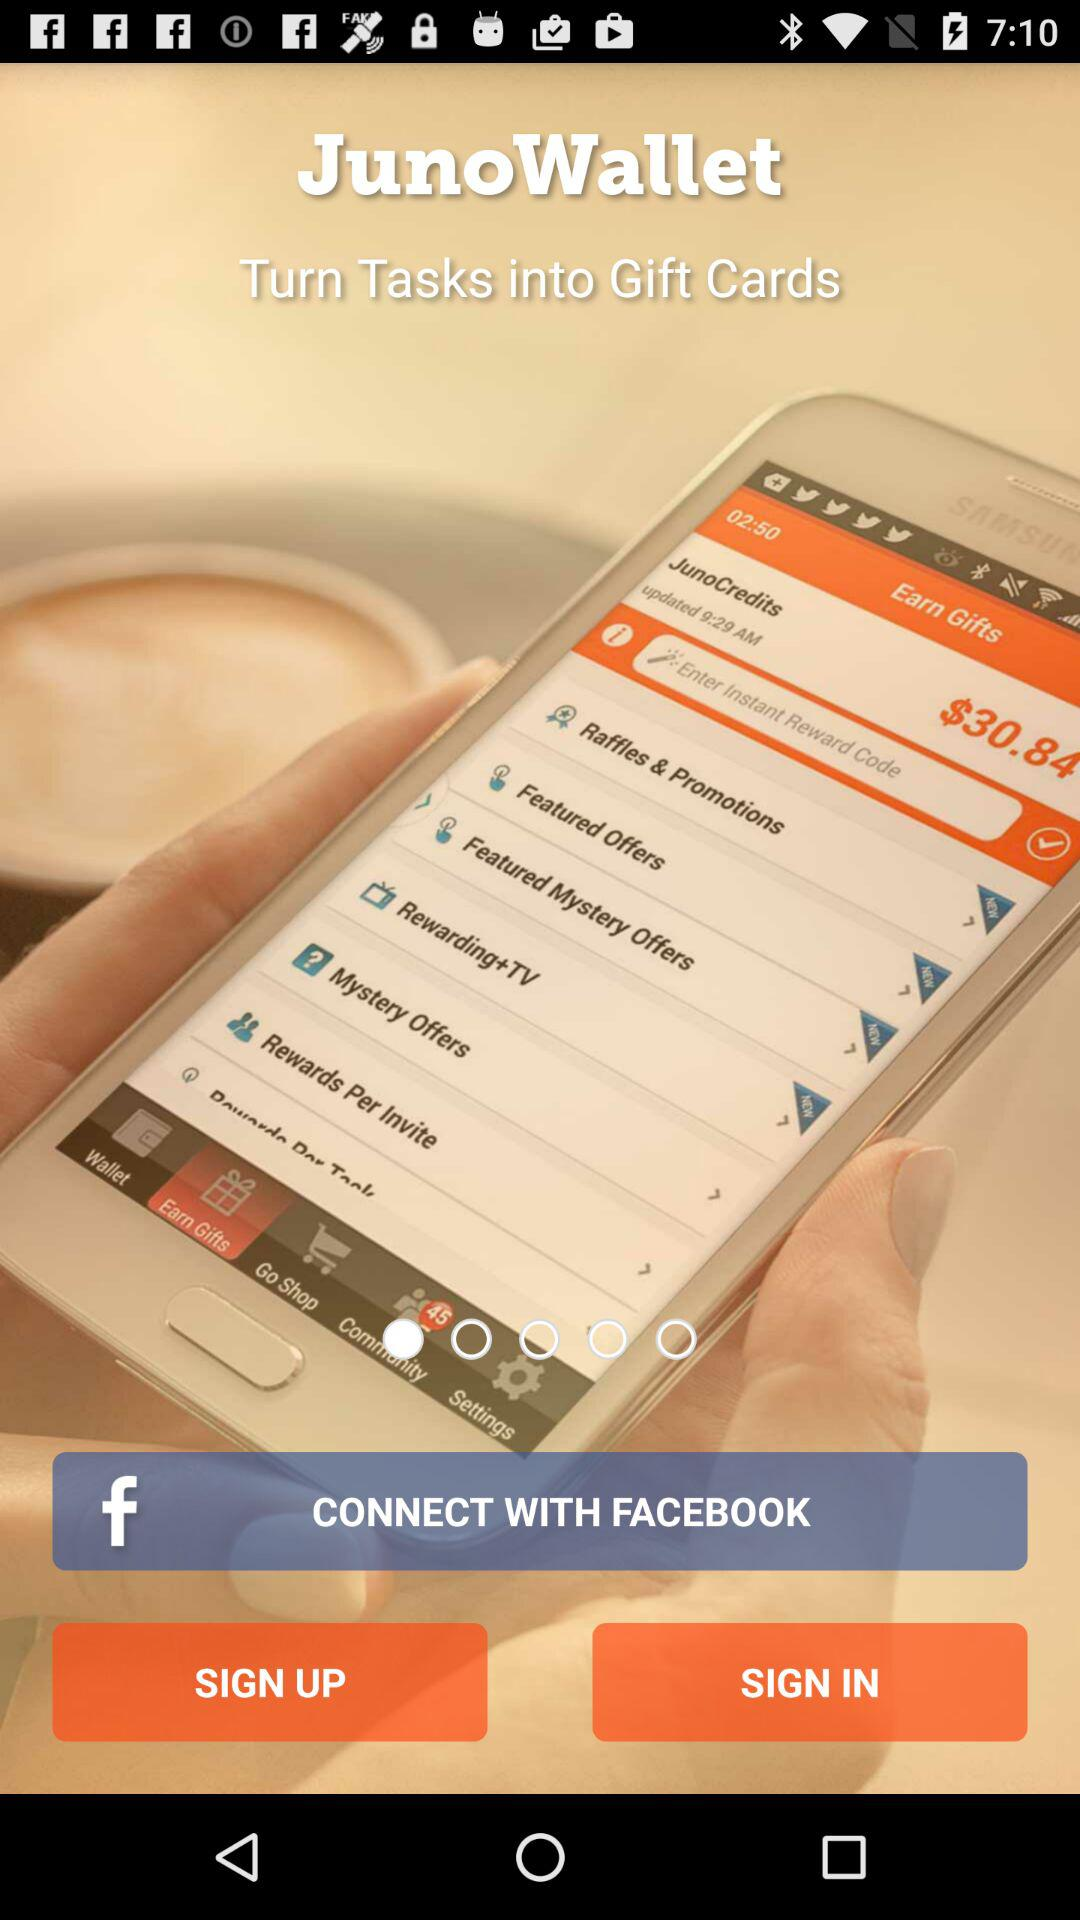Through what app can we connect? You can connect through "FACEBOOK". 